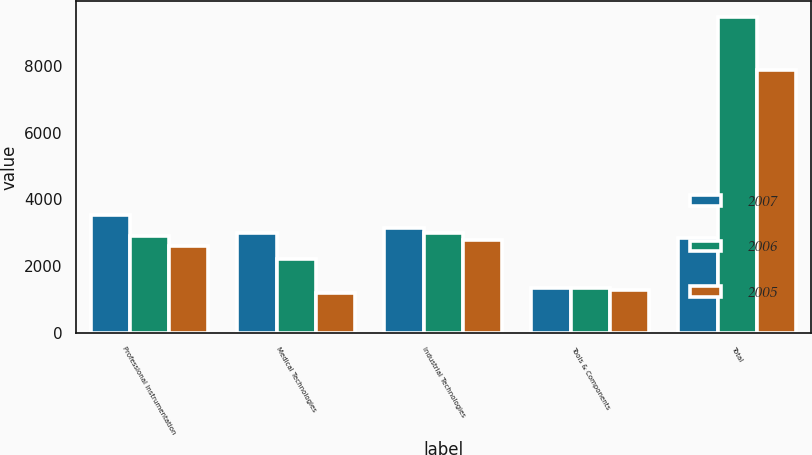Convert chart to OTSL. <chart><loc_0><loc_0><loc_500><loc_500><stacked_bar_chart><ecel><fcel>Professional Instrumentation<fcel>Medical Technologies<fcel>Industrial Technologies<fcel>Tools & Components<fcel>Total<nl><fcel>2007<fcel>3537.9<fcel>2998<fcel>3153.4<fcel>1336.6<fcel>2850.7<nl><fcel>2006<fcel>2906.5<fcel>2220<fcel>2988.8<fcel>1350.8<fcel>9466.1<nl><fcel>2005<fcel>2600.6<fcel>1181.5<fcel>2794.9<fcel>1294.5<fcel>7871.5<nl></chart> 